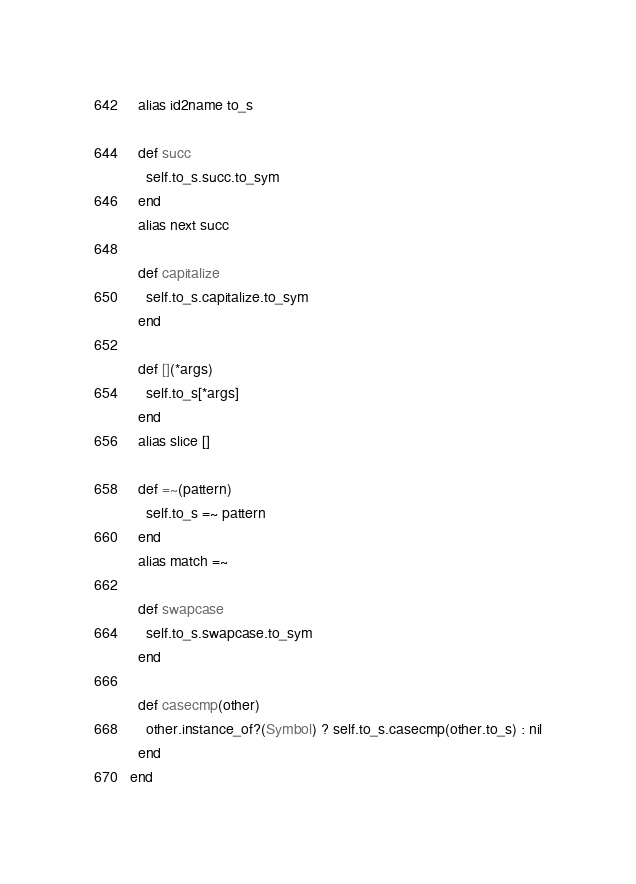Convert code to text. <code><loc_0><loc_0><loc_500><loc_500><_Ruby_>
  alias id2name to_s

  def succ
    self.to_s.succ.to_sym
  end
  alias next succ

  def capitalize
    self.to_s.capitalize.to_sym
  end

  def [](*args)
    self.to_s[*args]
  end
  alias slice []

  def =~(pattern)
    self.to_s =~ pattern
  end
  alias match =~

  def swapcase
    self.to_s.swapcase.to_sym
  end

  def casecmp(other)
    other.instance_of?(Symbol) ? self.to_s.casecmp(other.to_s) : nil
  end
end
</code> 